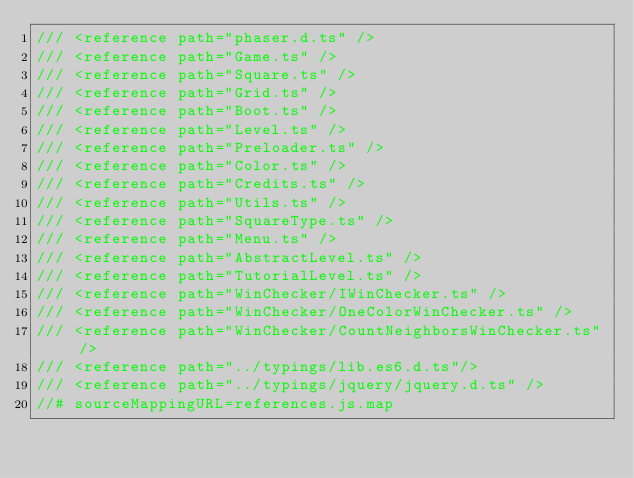Convert code to text. <code><loc_0><loc_0><loc_500><loc_500><_JavaScript_>/// <reference path="phaser.d.ts" />
/// <reference path="Game.ts" />
/// <reference path="Square.ts" />
/// <reference path="Grid.ts" />
/// <reference path="Boot.ts" />
/// <reference path="Level.ts" />
/// <reference path="Preloader.ts" />
/// <reference path="Color.ts" />
/// <reference path="Credits.ts" />
/// <reference path="Utils.ts" />
/// <reference path="SquareType.ts" />
/// <reference path="Menu.ts" />
/// <reference path="AbstractLevel.ts" />
/// <reference path="TutorialLevel.ts" />
/// <reference path="WinChecker/IWinChecker.ts" />
/// <reference path="WinChecker/OneColorWinChecker.ts" />
/// <reference path="WinChecker/CountNeighborsWinChecker.ts" />
/// <reference path="../typings/lib.es6.d.ts"/>
/// <reference path="../typings/jquery/jquery.d.ts" />
//# sourceMappingURL=references.js.map</code> 